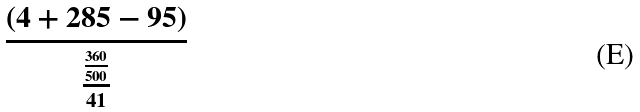<formula> <loc_0><loc_0><loc_500><loc_500>\frac { ( 4 + 2 8 5 - 9 5 ) } { \frac { \frac { 3 6 0 } { 5 0 0 } } { 4 1 } }</formula> 